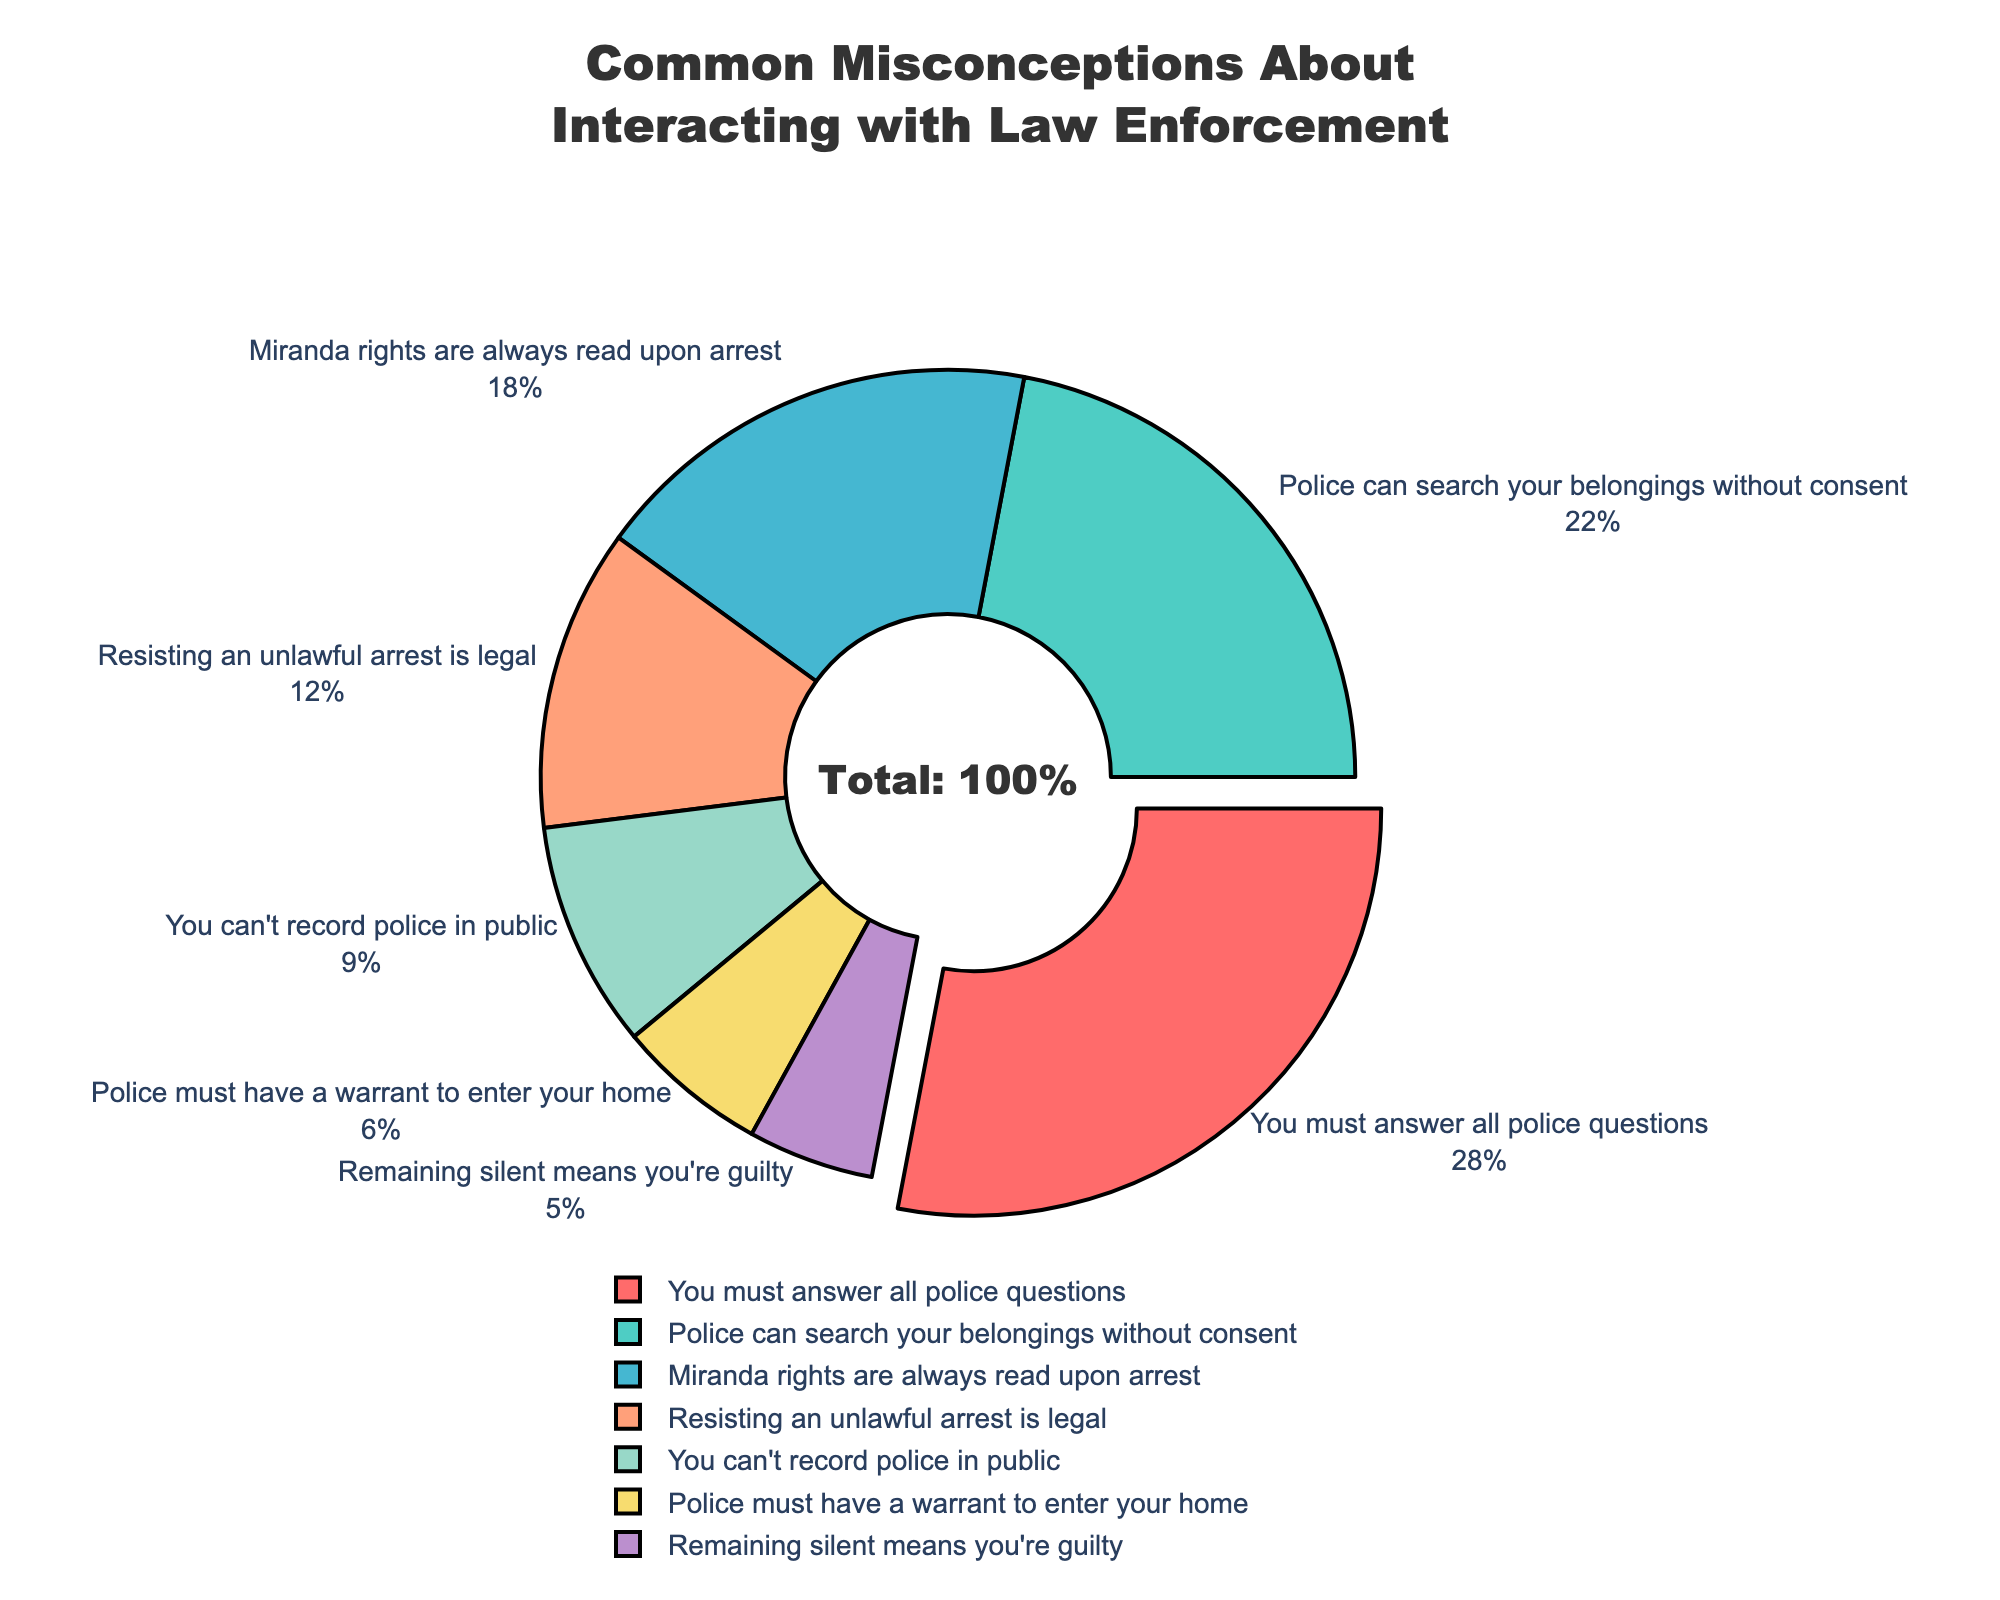What's the most common misconception among students about interacting with law enforcement? The largest segment of the pie chart, emphasized visually by being slightly pulled out, corresponds to the misconception "You must answer all police questions" with 28%. This indicates it is the most common misconception.
Answer: "You must answer all police questions" Which misconception is less common: "Police must have a warrant to enter your home" or "You can't record police in public"? By comparing the segments, "You can't record police in public" is represented by a larger segment (9%) than "Police must have a warrant to enter your home" (6%), indicating that the former is more common.
Answer: "Police must have a warrant to enter your home" What is the combined percentage of the misconceptions related to police's authority to search and arrest ("Police can search your belongings without consent" and "Resisting an unlawful arrest is legal")? Adding the percentages of "Police can search your belongings without consent" (22%) and "Resisting an unlawful arrest is legal" (12%): 22 + 12 = 34%
Answer: 34% Compare the misconception "Miranda rights are always read upon arrest" to "Remaining silent means you're guilty" in terms of their proportions. Which is more prevalent and by how much? The percentage for "Miranda rights are always read upon arrest" is 18%, while "Remaining silent means you're guilty" is 5%. The difference is 18 - 5 = 13%, showing "Miranda rights are always read upon arrest" is 13% more prevalent.
Answer: "Miranda rights are always read upon arrest", 13% What fraction of the total misconceptions does the least common misconception represent? The least common misconception is "Remaining silent means you're guilty" at 5%. Given the total misconceptions represent 100%, the fraction is 5/100 = 0.05. The fraction is 1/20, as 5% simplifies to 1/20.
Answer: 1/20 What percentage of misconceptions are related to answering police questions and the legality of resisting arrest combined? Adding the percentages of "You must answer all police questions" (28%) and "Resisting an unlawful arrest is legal" (12%): 28 + 12 = 40%
Answer: 40% Which misconception is represented by a blue segment in the pie chart? Observing the color segments in the pie chart, the blue segment corresponds to "Police can search your belongings without consent".
Answer: "Police can search your belongings without consent" If the segment for "You must answer all police questions" was not pulled out, how would you visually differentiate it as the largest segment? The largest segment is typically identified by its relative size compared to others. Without being pulled out, it remains the widest segment in the chart, and other elements like labeling and percentages outside the segments still indicate its prominence.
Answer: By size and label 